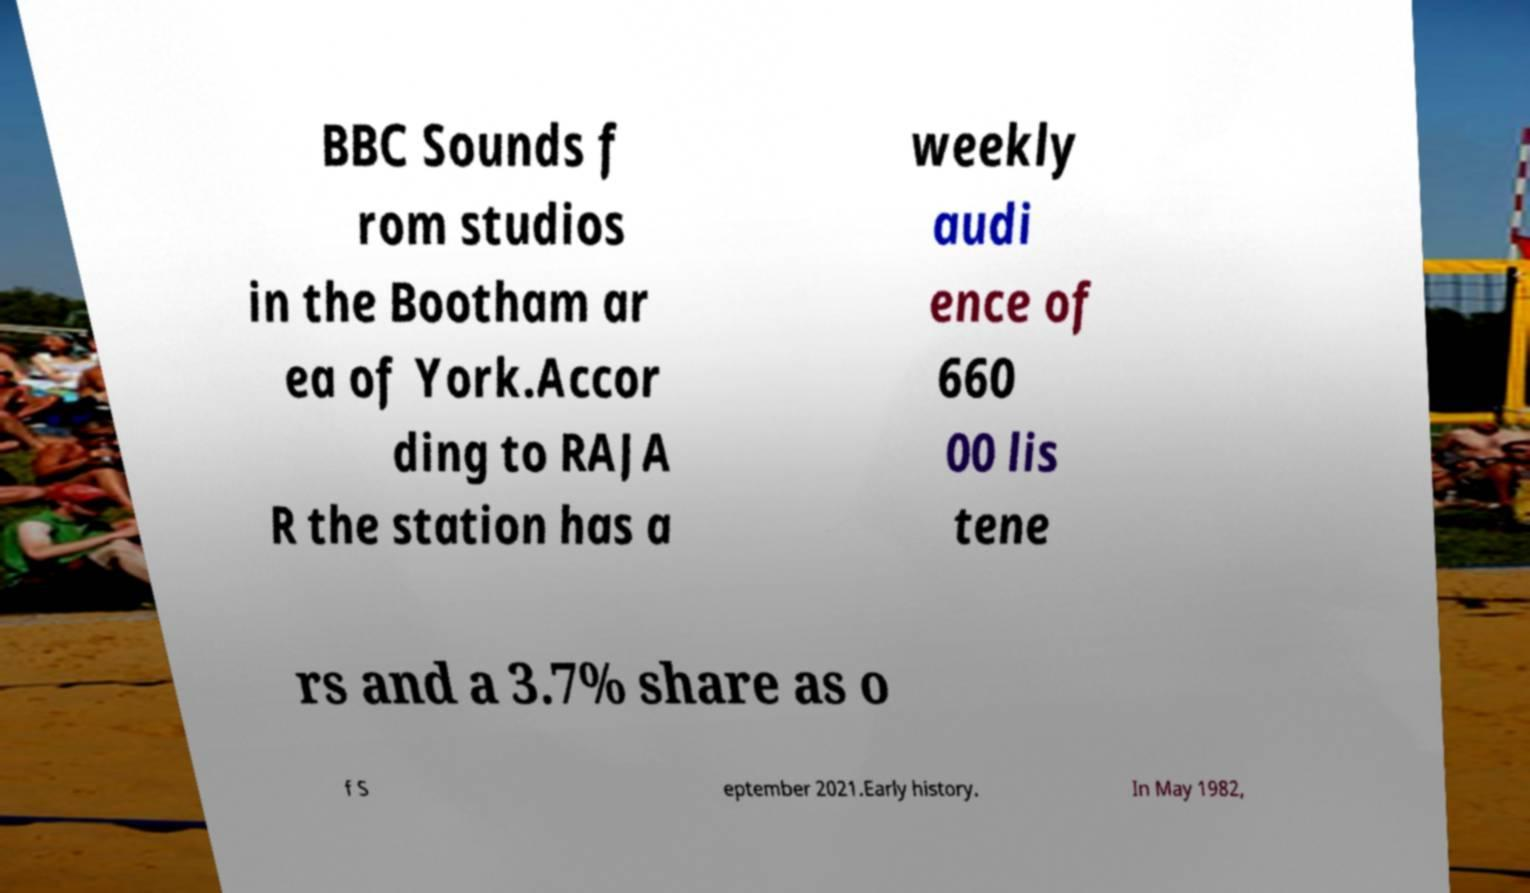Could you extract and type out the text from this image? BBC Sounds f rom studios in the Bootham ar ea of York.Accor ding to RAJA R the station has a weekly audi ence of 660 00 lis tene rs and a 3.7% share as o f S eptember 2021.Early history. In May 1982, 